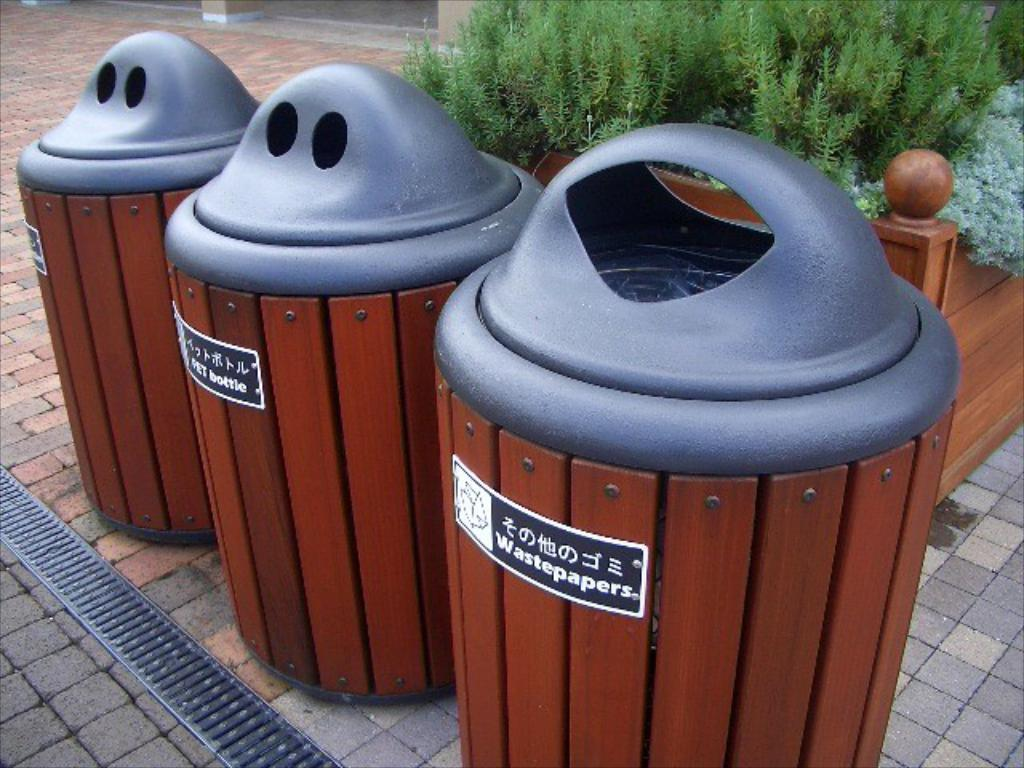<image>
Present a compact description of the photo's key features. Three trash cans where one is for wastepapers and the other for bottles. 